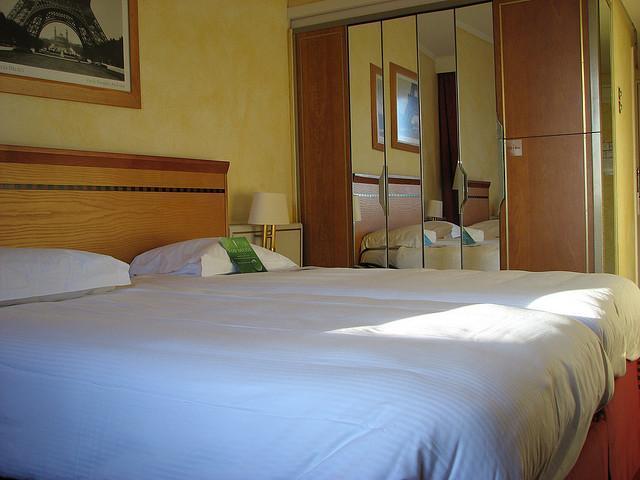How many pillows are on the bed?
Give a very brief answer. 2. How many beds can you see?
Give a very brief answer. 2. 